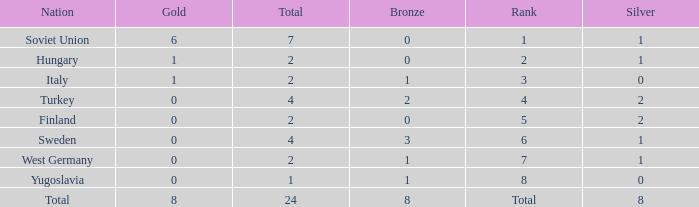What is the sum of Total, when Silver is 0, and when Gold is 1? 2.0. 